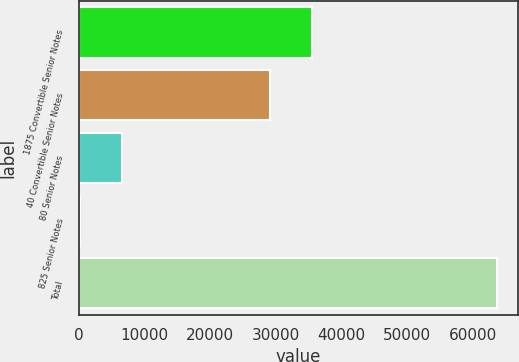Convert chart to OTSL. <chart><loc_0><loc_0><loc_500><loc_500><bar_chart><fcel>1875 Convertible Senior Notes<fcel>40 Convertible Senior Notes<fcel>80 Senior Notes<fcel>825 Senior Notes<fcel>Total<nl><fcel>35488.2<fcel>29149<fcel>6576.2<fcel>237<fcel>63629<nl></chart> 